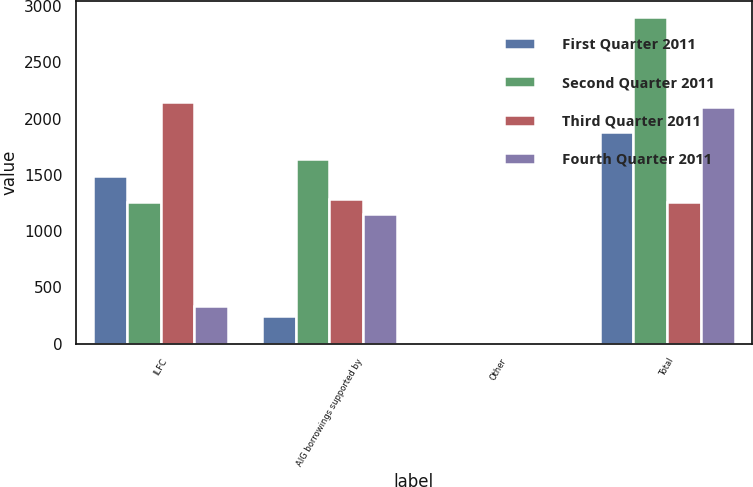Convert chart to OTSL. <chart><loc_0><loc_0><loc_500><loc_500><stacked_bar_chart><ecel><fcel>ILFC<fcel>AIG borrowings supported by<fcel>Other<fcel>Total<nl><fcel>First Quarter 2011<fcel>1489<fcel>248<fcel>1<fcel>1884<nl><fcel>Second Quarter 2011<fcel>1262<fcel>1637<fcel>1<fcel>2900<nl><fcel>Third Quarter 2011<fcel>2148<fcel>1284<fcel>1<fcel>1262<nl><fcel>Fourth Quarter 2011<fcel>336<fcel>1151<fcel>1<fcel>2106<nl></chart> 